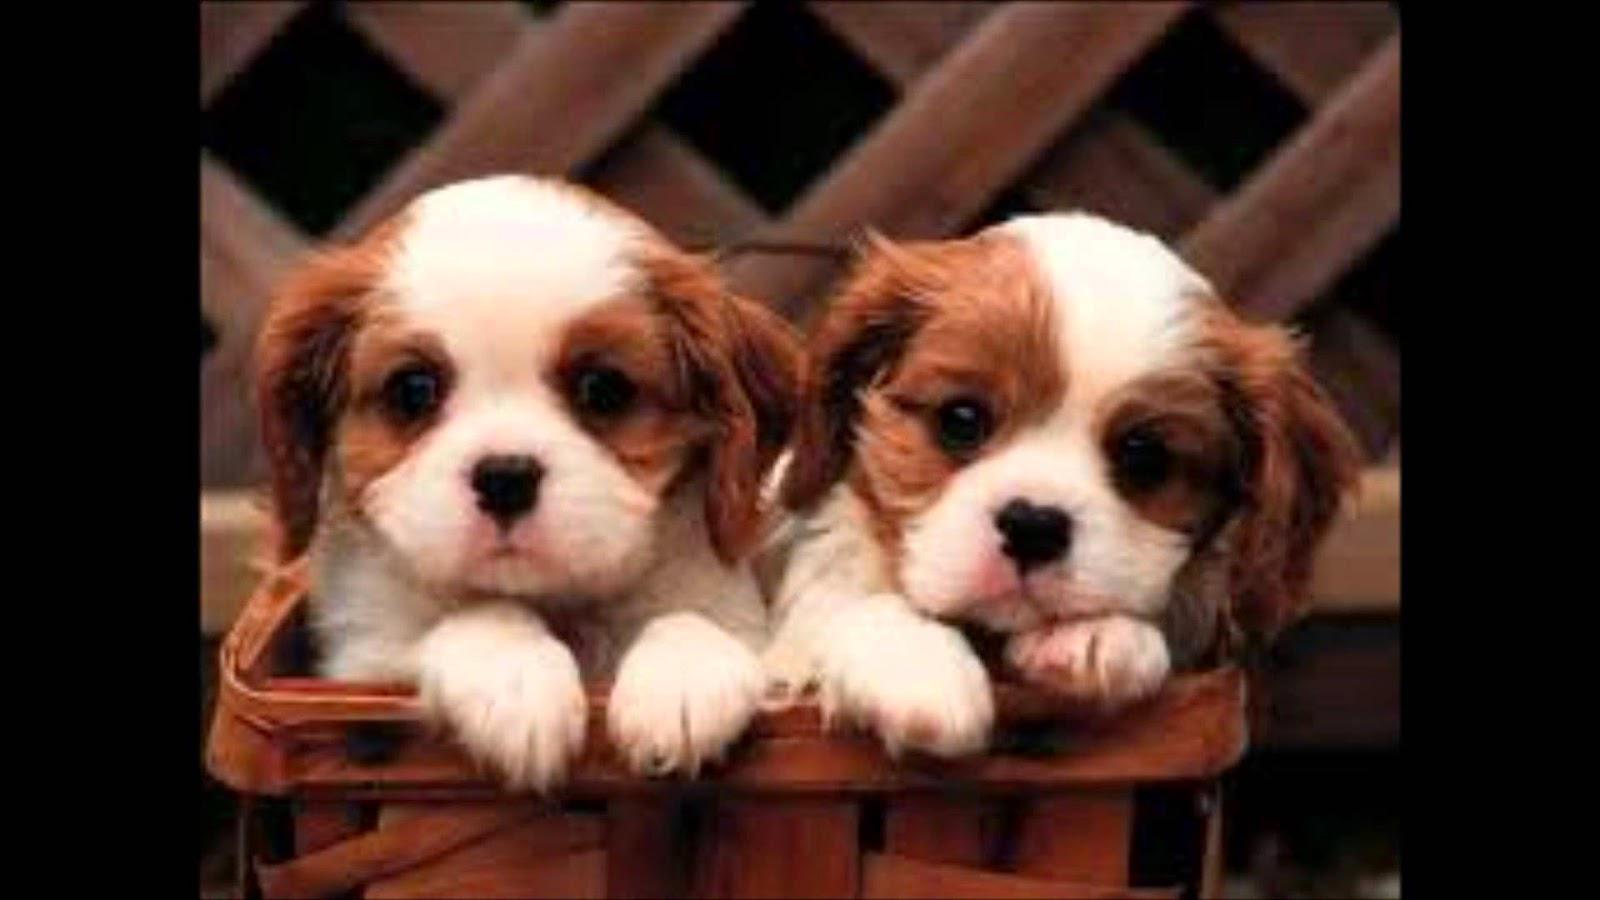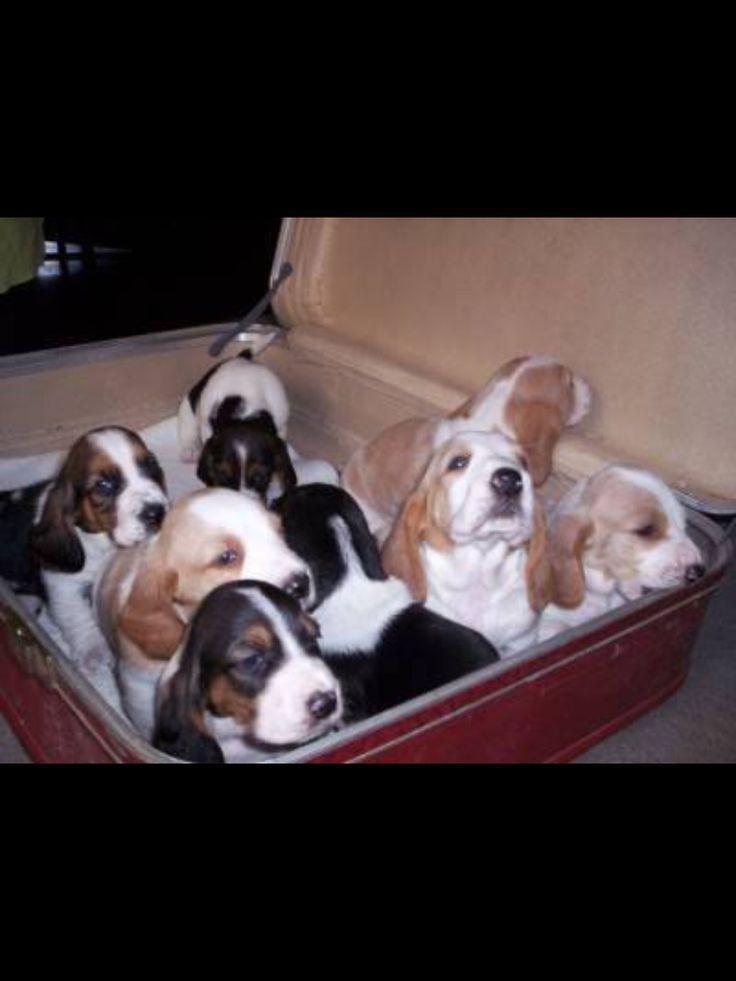The first image is the image on the left, the second image is the image on the right. Evaluate the accuracy of this statement regarding the images: "Each image shows exactly one dog, which is a long-eared hound.". Is it true? Answer yes or no. No. The first image is the image on the left, the second image is the image on the right. For the images displayed, is the sentence "There are a total of 4 dogs" factually correct? Answer yes or no. No. 